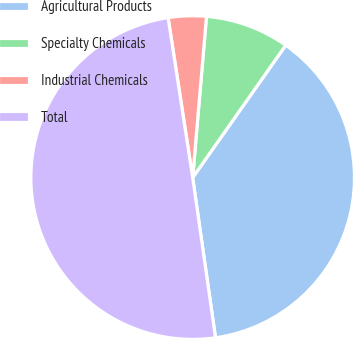<chart> <loc_0><loc_0><loc_500><loc_500><pie_chart><fcel>Agricultural Products<fcel>Specialty Chemicals<fcel>Industrial Chemicals<fcel>Total<nl><fcel>37.99%<fcel>8.39%<fcel>3.79%<fcel>49.83%<nl></chart> 